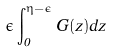Convert formula to latex. <formula><loc_0><loc_0><loc_500><loc_500>\epsilon \int _ { 0 } ^ { \eta - \epsilon } G ( z ) d z</formula> 